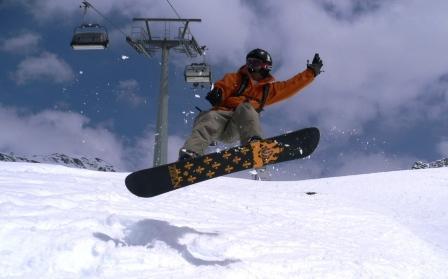What use would sitting in the seats have?
Indicate the correct response and explain using: 'Answer: answer
Rationale: rationale.'
Options: Up/downhill transport, avoiding sun, avoiding rain, dining. Answer: up/downhill transport.
Rationale: The ski lift brings people back to the mountaintop so they can ski down it again. 